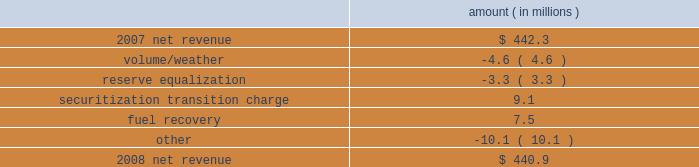Entergy texas , inc .
Management's financial discussion and analysis net revenue 2008 compared to 2007 net revenue consists of operating revenues net of : 1 ) fuel , fuel-related expenses , and gas purchased for resale , 2 ) purchased power expenses , and 3 ) other regulatory charges .
Following is an analysis of the change in net revenue comparing 2008 to 2007 .
Amount ( in millions ) .
The volume/weather variance is primarily due to decreased usage during the unbilled sales period .
See "critical accounting estimates" below and note 1 to the financial statements for further discussion of the accounting for unbilled revenues .
The reserve equalization variance is primarily due to lower reserve equalization revenue related to changes in the entergy system generation mix compared to the same period in 2007 .
The securitization transition charge variance is primarily due to the issuance of securitization bonds .
In june 2007 , entergy gulf states reconstruction funding i , a company wholly-owned and consolidated by entergy texas , issued securitization bonds and with the proceeds purchased from entergy texas the transition property , which is the right to recover from customers through a transition charge amounts sufficient to service the securitization bonds .
See note 5 to the financial statements for additional information regarding the securitization bonds .
The fuel recovery variance is primarily due to a reserve for potential rate refunds made in the first quarter 2007 as a result of a puct ruling related to the application of past puct rulings addressing transition to competition in texas .
The other variance is primarily caused by various operational effects of the jurisdictional separation on revenues and fuel and purchased power expenses .
Gross operating revenues , fuel and purchased power expenses , and other regulatory charges gross operating revenues increased $ 229.3 million primarily due to the following reasons : an increase of $ 157 million in fuel cost recovery revenues due to higher fuel rates and increased usage , partially offset by interim fuel refunds to customers for fuel cost recovery over-collections through november 2007 .
The refund was distributed over a two-month period beginning february 2008 .
The interim refund and the puct approval is discussed in note 2 to the financial statements ; an increase of $ 37.1 million in affiliated wholesale revenue primarily due to increases in the cost of energy ; an increase in transition charge amounts collected from customers to service the securitization bonds as discussed above .
See note 5 to the financial statements for additional information regarding the securitization bonds ; and implementation of an interim surcharge to collect $ 10.3 million in under-recovered incremental purchased capacity costs incurred through july 2007 .
The surcharge was collected over a two-month period beginning february 2008 .
The incremental capacity recovery rider and puct approval is discussed in note 2 to the financial statements. .
What is the percent change in net revenue between 2007 and 2008? 
Computations: ((440.9 - 442.3) / 442.3)
Answer: -0.00317. 